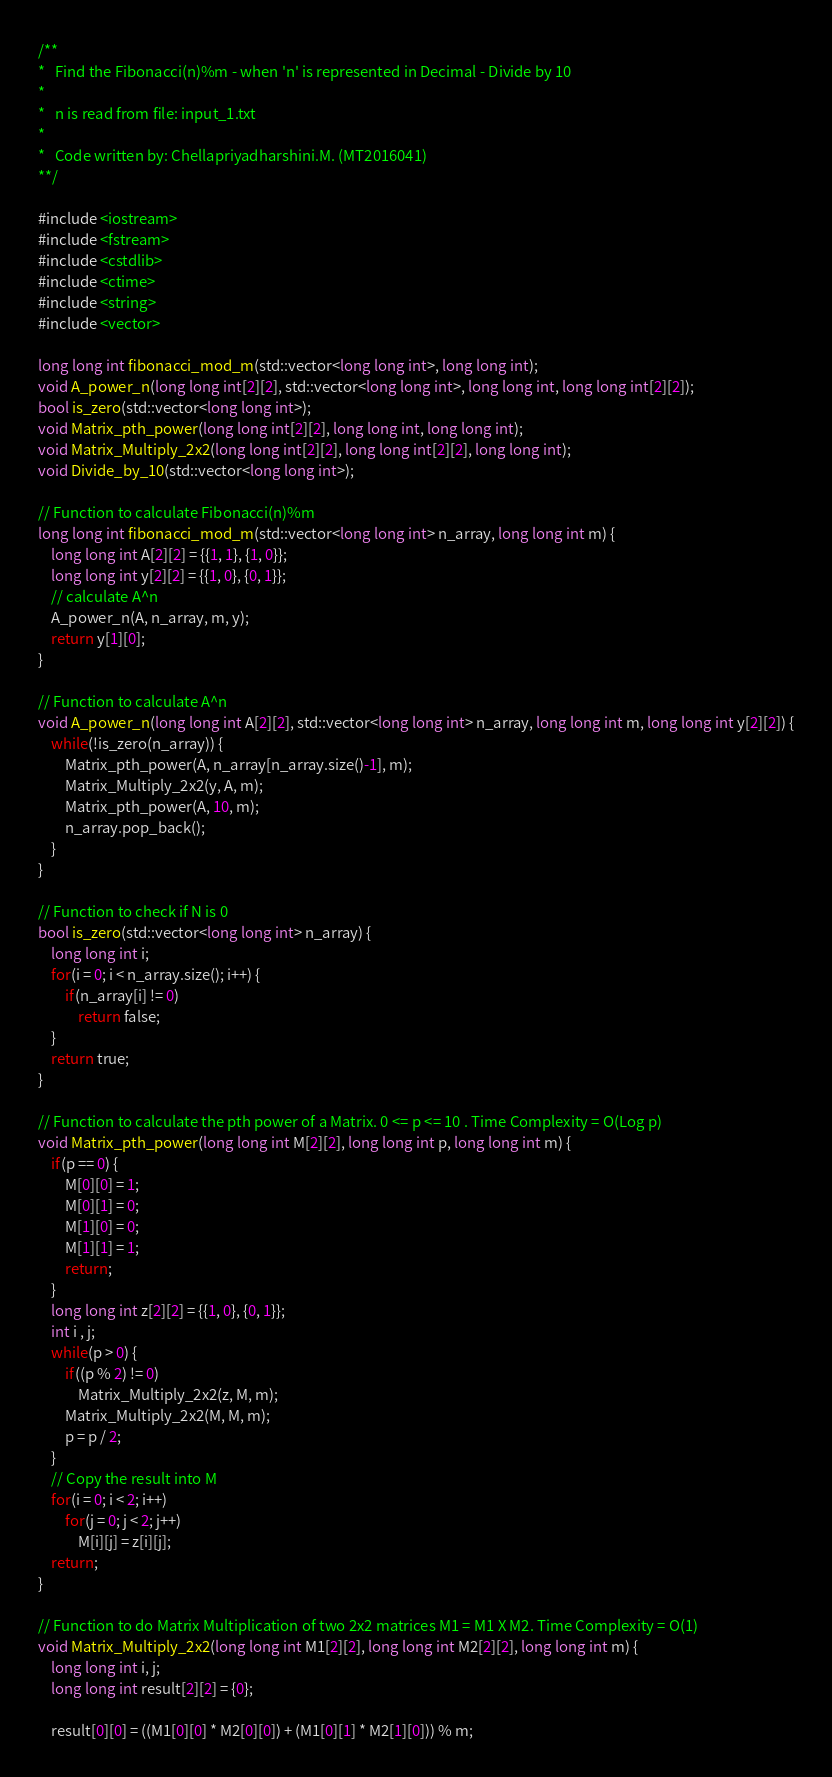<code> <loc_0><loc_0><loc_500><loc_500><_C++_>/**
*	Find the Fibonacci(n)%m - when 'n' is represented in Decimal - Divide by 10
*
*	n is read from file: input_1.txt
*
*	Code written by: Chellapriyadharshini.M. (MT2016041)
**/

#include <iostream>
#include <fstream>
#include <cstdlib>
#include <ctime>
#include <string>
#include <vector>

long long int fibonacci_mod_m(std::vector<long long int>, long long int);
void A_power_n(long long int[2][2], std::vector<long long int>, long long int, long long int[2][2]);
bool is_zero(std::vector<long long int>);
void Matrix_pth_power(long long int[2][2], long long int, long long int);
void Matrix_Multiply_2x2(long long int[2][2], long long int[2][2], long long int);
void Divide_by_10(std::vector<long long int>);

// Function to calculate Fibonacci(n)%m
long long int fibonacci_mod_m(std::vector<long long int> n_array, long long int m) {
	long long int A[2][2] = {{1, 1}, {1, 0}};
	long long int y[2][2] = {{1, 0}, {0, 1}};
	// calculate A^n
	A_power_n(A, n_array, m, y);
	return y[1][0];
}

// Function to calculate A^n
void A_power_n(long long int A[2][2], std::vector<long long int> n_array, long long int m, long long int y[2][2]) {
	while(!is_zero(n_array)) {
		Matrix_pth_power(A, n_array[n_array.size()-1], m);
		Matrix_Multiply_2x2(y, A, m);
		Matrix_pth_power(A, 10, m);
		n_array.pop_back();
	}
}

// Function to check if N is 0
bool is_zero(std::vector<long long int> n_array) {
	long long int i;
	for(i = 0; i < n_array.size(); i++) {
		if(n_array[i] != 0)
			return false;
	}
	return true;
}

// Function to calculate the pth power of a Matrix. 0 <= p <= 10 . Time Complexity = O(Log p)
void Matrix_pth_power(long long int M[2][2], long long int p, long long int m) {
	if(p == 0) {
		M[0][0] = 1;
		M[0][1] = 0;
		M[1][0] = 0;
		M[1][1] = 1;
		return;
	}
	long long int z[2][2] = {{1, 0}, {0, 1}};
	int i , j;
	while(p > 0) {
		if((p % 2) != 0)
			Matrix_Multiply_2x2(z, M, m);
		Matrix_Multiply_2x2(M, M, m);
		p = p / 2;
	}
	// Copy the result into M
	for(i = 0; i < 2; i++)
		for(j = 0; j < 2; j++)
			M[i][j] = z[i][j];
	return;
}

// Function to do Matrix Multiplication of two 2x2 matrices M1 = M1 X M2. Time Complexity = O(1)
void Matrix_Multiply_2x2(long long int M1[2][2], long long int M2[2][2], long long int m) {
	long long int i, j;
	long long int result[2][2] = {0};

	result[0][0] = ((M1[0][0] * M2[0][0]) + (M1[0][1] * M2[1][0])) % m;</code> 